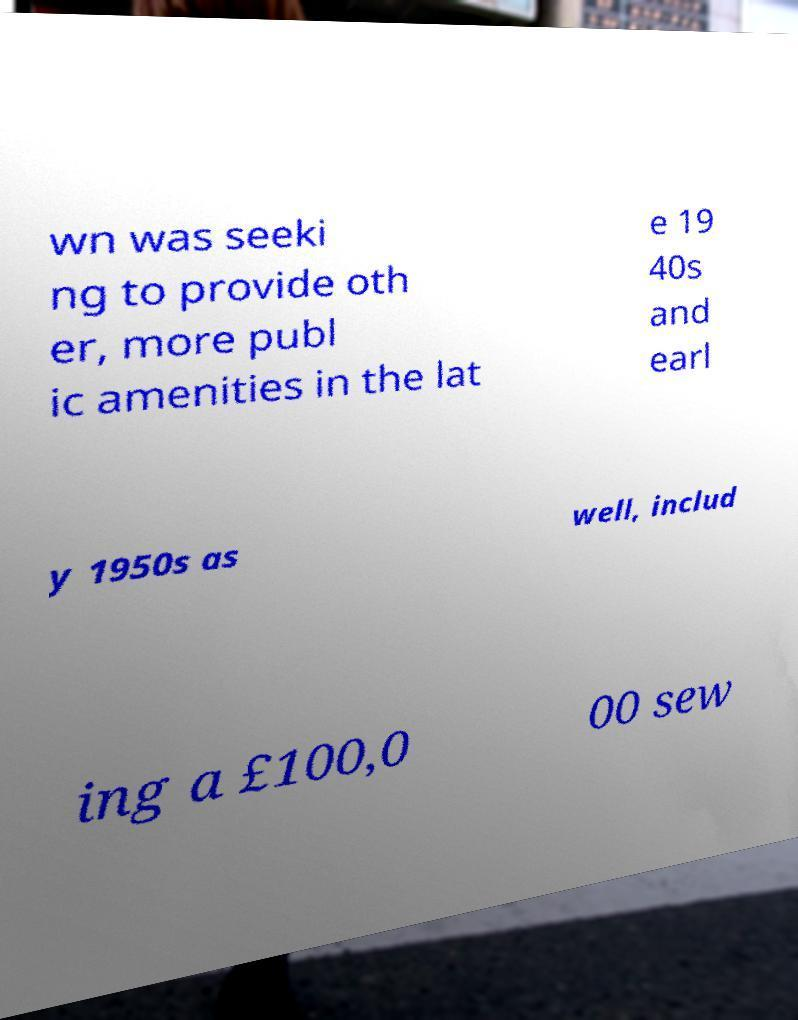What messages or text are displayed in this image? I need them in a readable, typed format. wn was seeki ng to provide oth er, more publ ic amenities in the lat e 19 40s and earl y 1950s as well, includ ing a £100,0 00 sew 